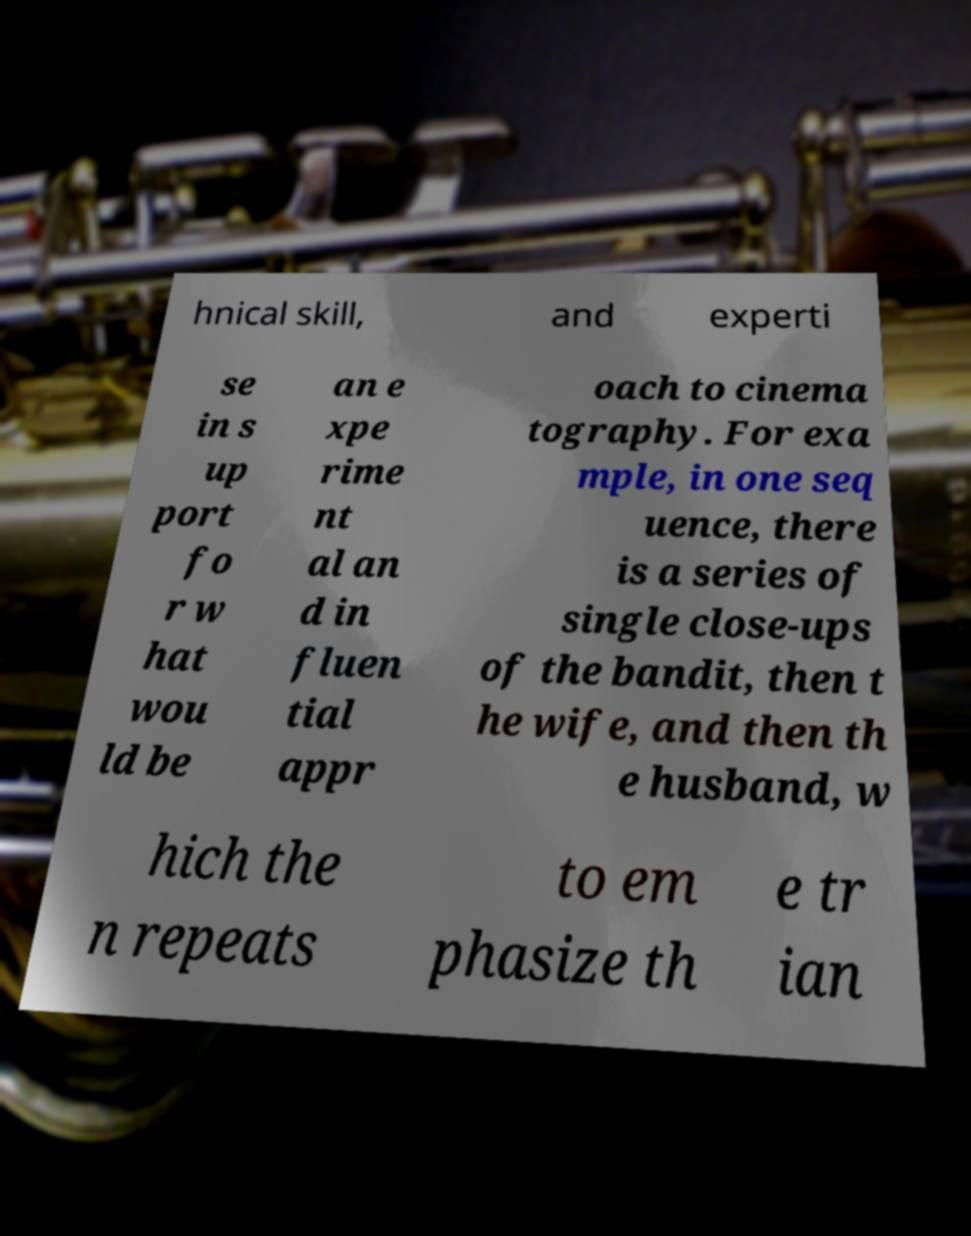Please identify and transcribe the text found in this image. hnical skill, and experti se in s up port fo r w hat wou ld be an e xpe rime nt al an d in fluen tial appr oach to cinema tography. For exa mple, in one seq uence, there is a series of single close-ups of the bandit, then t he wife, and then th e husband, w hich the n repeats to em phasize th e tr ian 